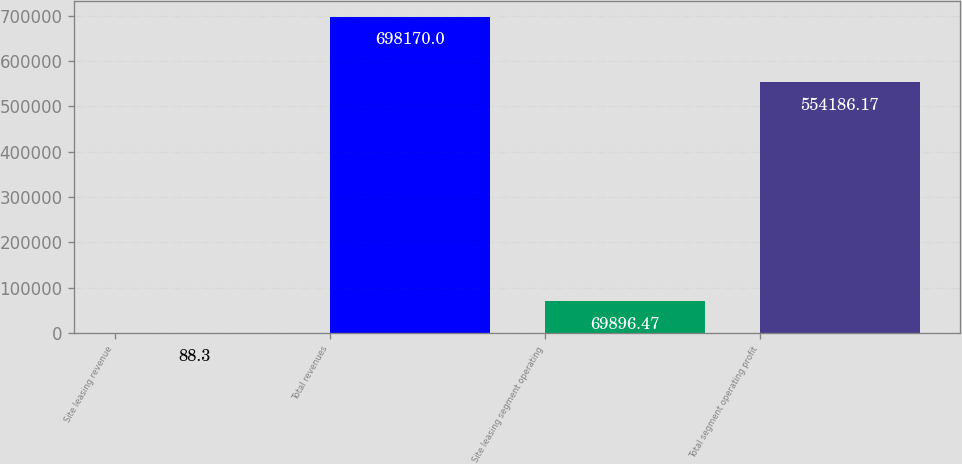Convert chart to OTSL. <chart><loc_0><loc_0><loc_500><loc_500><bar_chart><fcel>Site leasing revenue<fcel>Total revenues<fcel>Site leasing segment operating<fcel>Total segment operating profit<nl><fcel>88.3<fcel>698170<fcel>69896.5<fcel>554186<nl></chart> 